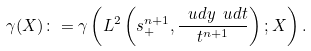Convert formula to latex. <formula><loc_0><loc_0><loc_500><loc_500>\gamma ( X ) \colon = \gamma \left ( L ^ { 2 } \left ( \real s ^ { n + 1 } _ { + } , \frac { \ u d y \ u d t } { t ^ { n + 1 } } \right ) ; X \right ) .</formula> 